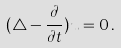<formula> <loc_0><loc_0><loc_500><loc_500>( \triangle - \frac { \partial } { \partial t } ) u = 0 \, .</formula> 